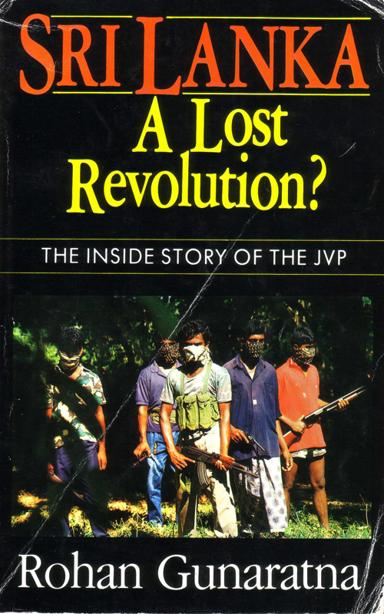What historical period does this book discuss, and what are the key events covered? The book discusses the late 20th-century insurgencies led by the Janatha Vimukthi Peramuna (JVP) in Sri Lanka, primarily focusing on the 1971 and the more devastating 1987-89 uprisings. Key events include the ideological battles, the violent clashes with governmental forces, and the internal strife within the JVP that characterized this turbulent period in Sri Lankan history. 